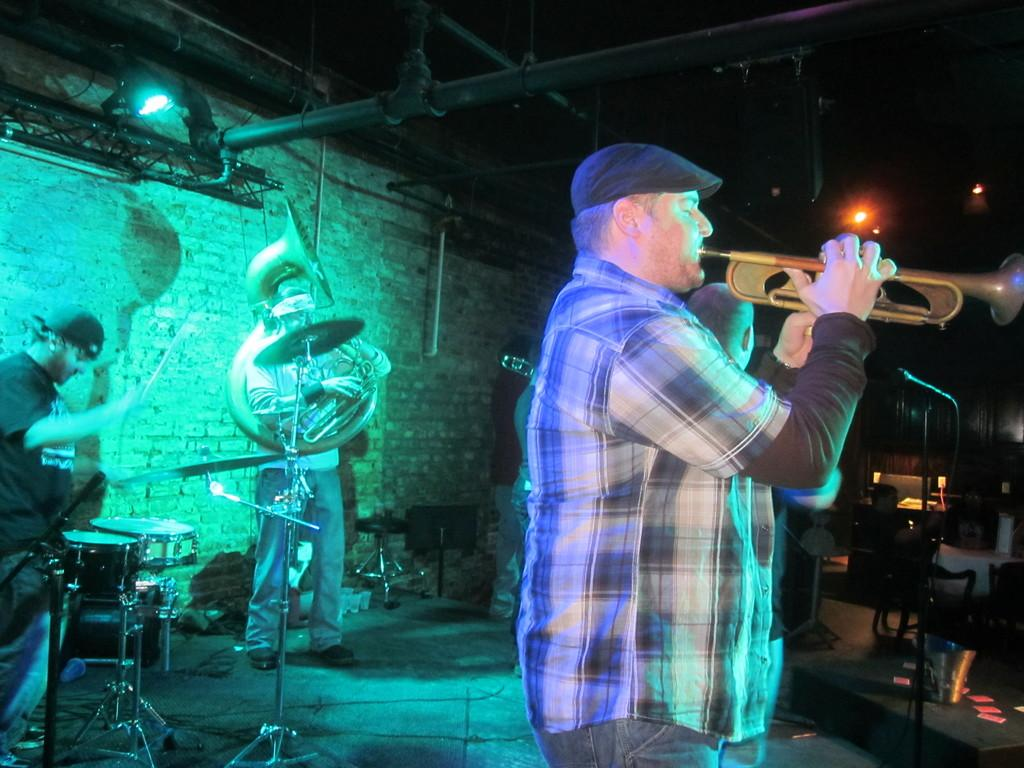How many people are in the image? There are three persons in the image. Where are the persons located in the image? The persons are standing on a stage. What are the persons doing in the image? The persons are playing musical instruments. What type of credit can be seen on the stage in the image? There is no credit visible on the stage in the image. How many earths can be seen in the image? There are no earths present in the image. 